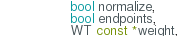<code> <loc_0><loc_0><loc_500><loc_500><_Cuda_>                 bool normalize,
                 bool endpoints,
                 WT const *weight,</code> 